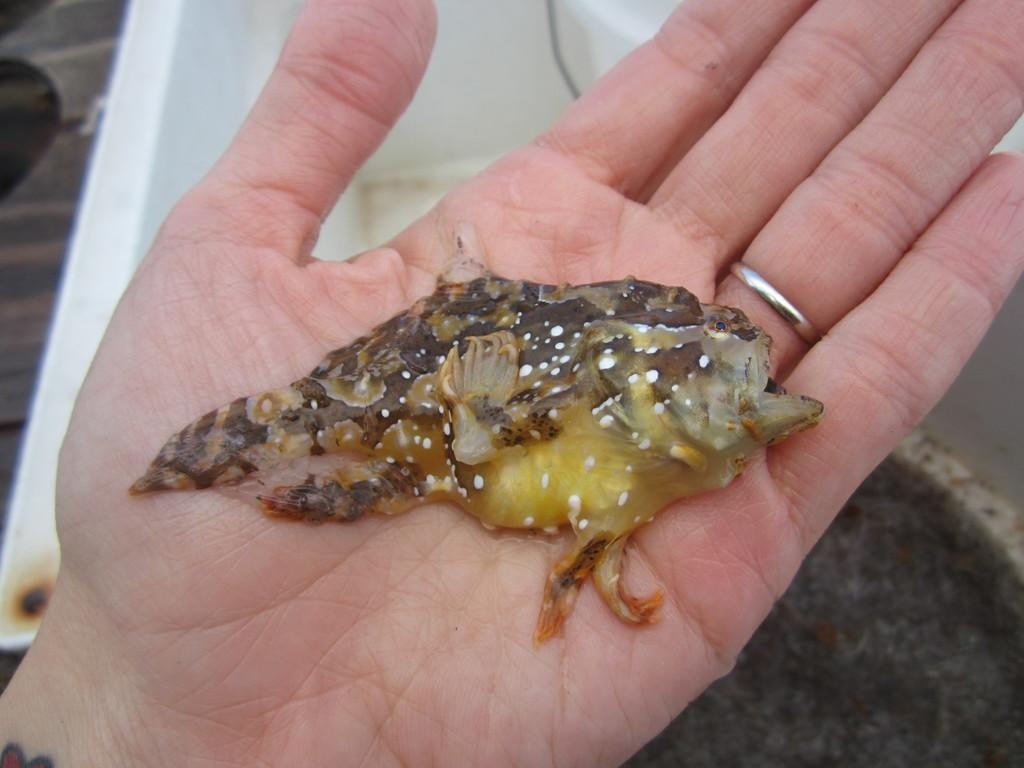How does the love for quicksand affect the class dynamics in the image? There is no image provided, and therefore no class dynamics or love for quicksand can be observed. 